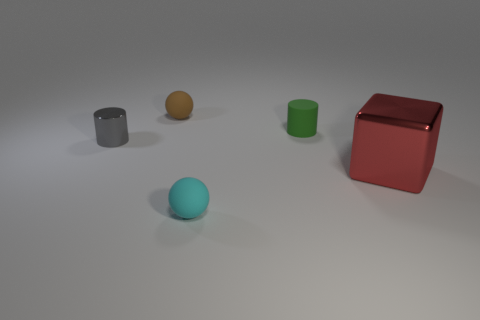Are there any other things that are the same size as the metal block?
Your answer should be very brief. No. Are there any large red things to the left of the red shiny block?
Ensure brevity in your answer.  No. What material is the small ball in front of the small rubber object behind the small rubber cylinder?
Keep it short and to the point. Rubber. What is the size of the matte object that is the same shape as the gray metal thing?
Your answer should be very brief. Small. Is the color of the cube the same as the tiny shiny cylinder?
Keep it short and to the point. No. The object that is both on the right side of the brown rubber object and on the left side of the small green matte cylinder is what color?
Make the answer very short. Cyan. There is a cylinder in front of the green cylinder; does it have the same size as the small green object?
Provide a short and direct response. Yes. Is there anything else that has the same shape as the cyan rubber thing?
Your answer should be compact. Yes. Is the material of the gray cylinder the same as the small ball that is in front of the red metal block?
Offer a terse response. No. What number of gray objects are either matte spheres or big objects?
Your answer should be compact. 0. 